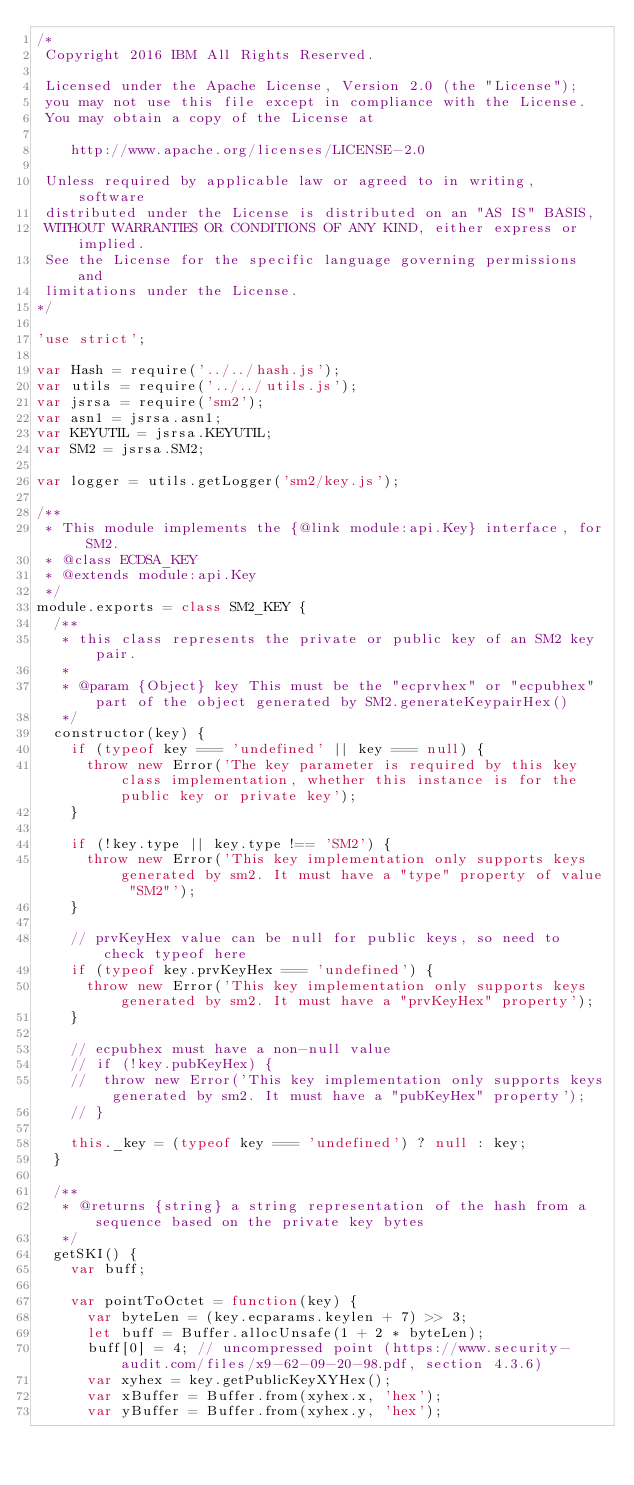Convert code to text. <code><loc_0><loc_0><loc_500><loc_500><_JavaScript_>/*
 Copyright 2016 IBM All Rights Reserved.

 Licensed under the Apache License, Version 2.0 (the "License");
 you may not use this file except in compliance with the License.
 You may obtain a copy of the License at

	  http://www.apache.org/licenses/LICENSE-2.0

 Unless required by applicable law or agreed to in writing, software
 distributed under the License is distributed on an "AS IS" BASIS,
 WITHOUT WARRANTIES OR CONDITIONS OF ANY KIND, either express or implied.
 See the License for the specific language governing permissions and
 limitations under the License.
*/

'use strict';

var Hash = require('../../hash.js');
var utils = require('../../utils.js');
var jsrsa = require('sm2');
var asn1 = jsrsa.asn1;
var KEYUTIL = jsrsa.KEYUTIL;
var SM2 = jsrsa.SM2;

var logger = utils.getLogger('sm2/key.js');

/**
 * This module implements the {@link module:api.Key} interface, for SM2.
 * @class ECDSA_KEY
 * @extends module:api.Key
 */
module.exports = class SM2_KEY {
	/**
	 * this class represents the private or public key of an SM2 key pair.
	 *
	 * @param {Object} key This must be the "ecprvhex" or "ecpubhex" part of the object generated by SM2.generateKeypairHex()
	 */
	constructor(key) {
		if (typeof key === 'undefined' || key === null) {
			throw new Error('The key parameter is required by this key class implementation, whether this instance is for the public key or private key');
		}

		if (!key.type || key.type !== 'SM2') {
			throw new Error('This key implementation only supports keys generated by sm2. It must have a "type" property of value "SM2"');
		}

		// prvKeyHex value can be null for public keys, so need to check typeof here
		if (typeof key.prvKeyHex === 'undefined') {
			throw new Error('This key implementation only supports keys generated by sm2. It must have a "prvKeyHex" property');
		}

		// ecpubhex must have a non-null value
		// if (!key.pubKeyHex) {
		// 	throw new Error('This key implementation only supports keys generated by sm2. It must have a "pubKeyHex" property');
		// }

		this._key = (typeof key === 'undefined') ? null : key;
	}

	/**
	 * @returns {string} a string representation of the hash from a sequence based on the private key bytes
	 */
	getSKI() {
		var buff;

		var pointToOctet = function(key) {
			var byteLen = (key.ecparams.keylen + 7) >> 3;
			let buff = Buffer.allocUnsafe(1 + 2 * byteLen);
			buff[0] = 4; // uncompressed point (https://www.security-audit.com/files/x9-62-09-20-98.pdf, section 4.3.6)
			var xyhex = key.getPublicKeyXYHex();
			var xBuffer = Buffer.from(xyhex.x, 'hex');
			var yBuffer = Buffer.from(xyhex.y, 'hex');</code> 